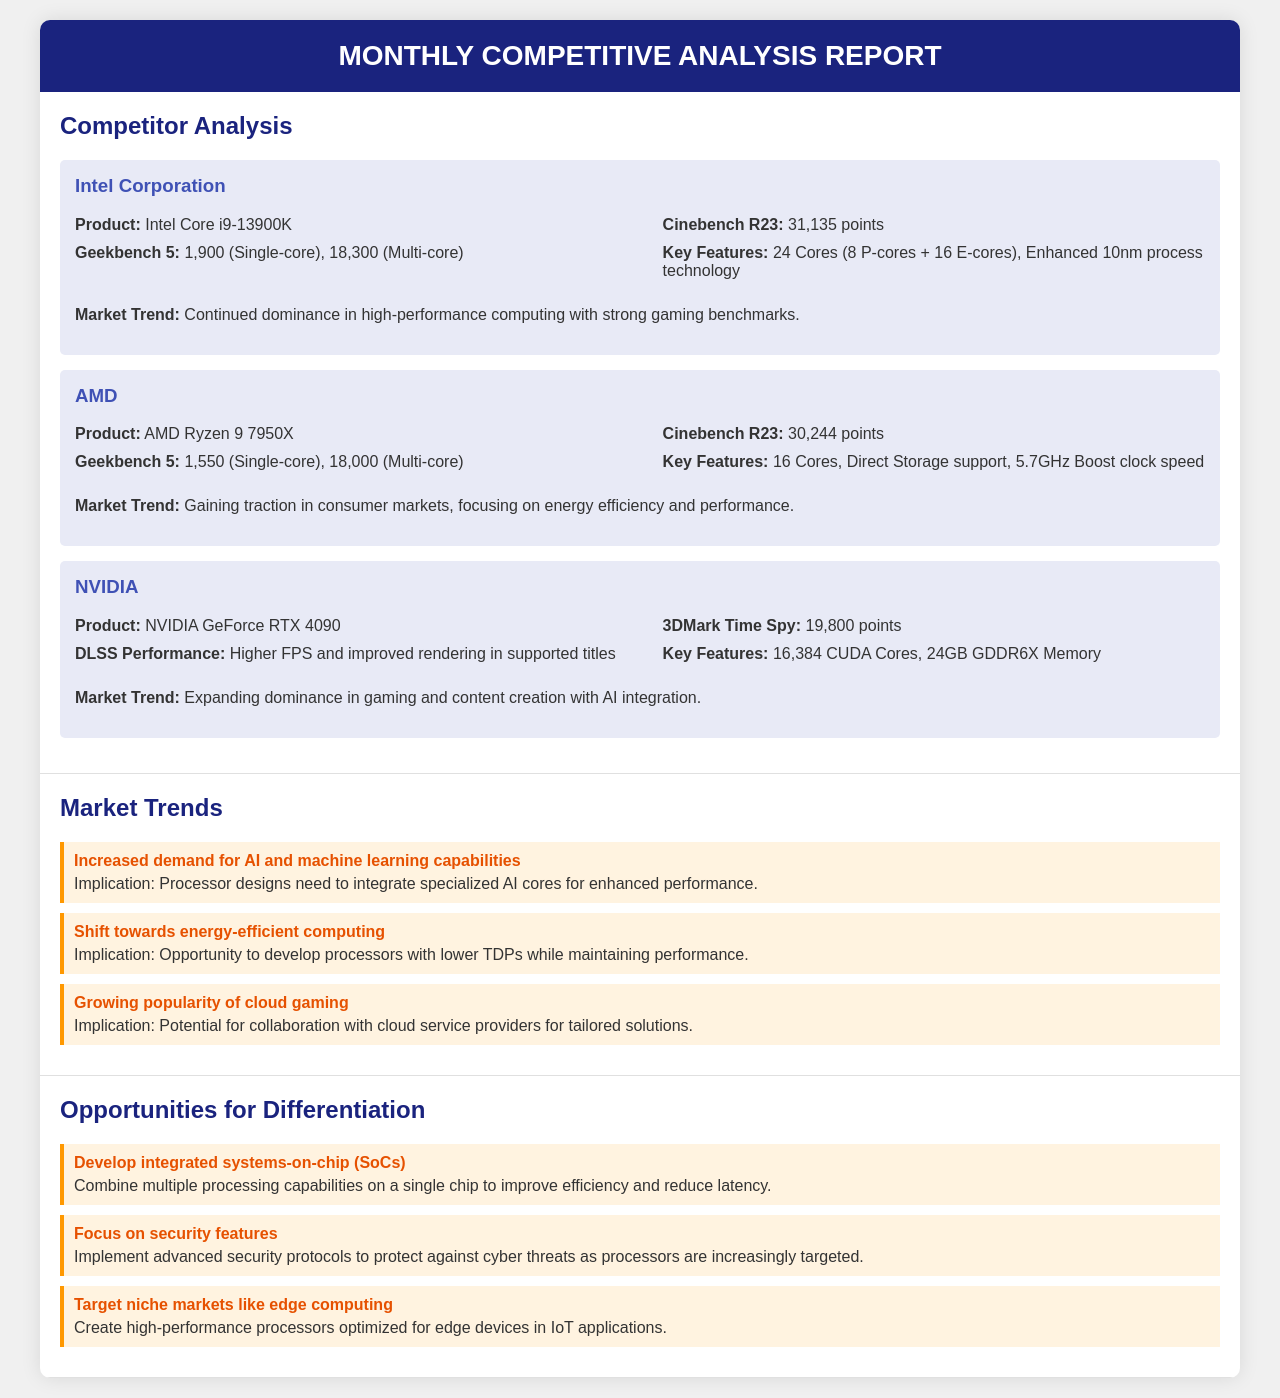What is the product name for Intel Corporation? The product name for Intel Corporation is listed as Intel Core i9-13900K in the document.
Answer: Intel Core i9-13900K What is the Cinebench R23 score for AMD? The Cinebench R23 score for AMD is 30,244 points, as specified in the competitor analysis.
Answer: 30,244 points Which competitor's product has the highest Geekbench 5 single-core score? The competitor analysis shows that Intel's product has the highest Geekbench 5 single-core score of 1,900.
Answer: 1,900 What is a key feature of the NVIDIA GeForce RTX 4090? The document lists a key feature of the NVIDIA GeForce RTX 4090 as having 16,384 CUDA Cores.
Answer: 16,384 CUDA Cores What opportunity for differentiation focuses on security features? The document states the opportunity focusing on security features involves implementing advanced security protocols.
Answer: Implement advanced security protocols What market trend involves energy-efficient computing? The trend that involves energy-efficient computing mentions an opportunity to develop processors with lower TDPs.
Answer: Shift towards energy-efficient computing How many cores does the AMD Ryzen 9 7950X have? The document specifies that the AMD Ryzen 9 7950X has 16 Cores.
Answer: 16 Cores What implication is associated with the increased demand for AI capabilities? The implication for increased demand for AI capabilities is that processor designs need to integrate specialized AI cores.
Answer: Integrate specialized AI cores What is the 3DMark Time Spy score for NVIDIA? According to the document, the 3DMark Time Spy score for NVIDIA is 19,800 points.
Answer: 19,800 points 